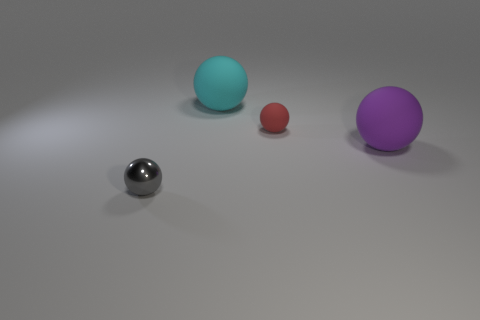Subtract 2 balls. How many balls are left? 2 Subtract all shiny balls. How many balls are left? 3 Subtract all purple balls. How many balls are left? 3 Subtract all blue balls. Subtract all cyan blocks. How many balls are left? 4 Add 4 red metal blocks. How many objects exist? 8 Add 3 tiny red rubber objects. How many tiny red rubber objects exist? 4 Subtract 0 cyan cubes. How many objects are left? 4 Subtract all shiny objects. Subtract all big rubber balls. How many objects are left? 1 Add 4 gray metal spheres. How many gray metal spheres are left? 5 